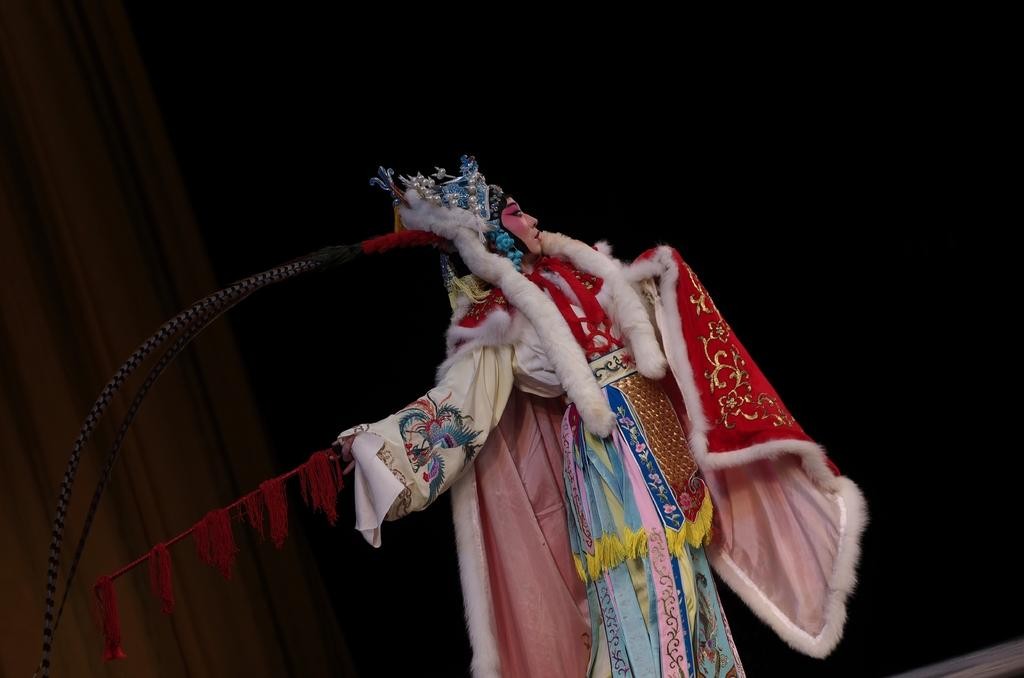Who is the main subject in the image? There is a lady in the center of the image. What can be observed about the lady's appearance? The lady is wearing cosmetics. What is located on the left side of the image? There is a curtain on the left side of the image. What part of the room can be seen at the bottom right corner of the image? The floor is visible at the bottom right corner of the image. What type of kite is being flown by the lady in the image? There is no kite present in the image; the lady is not flying a kite. What story is the lady telling in the image? There is no indication of a story being told in the image; the lady is simply present in the scene. 